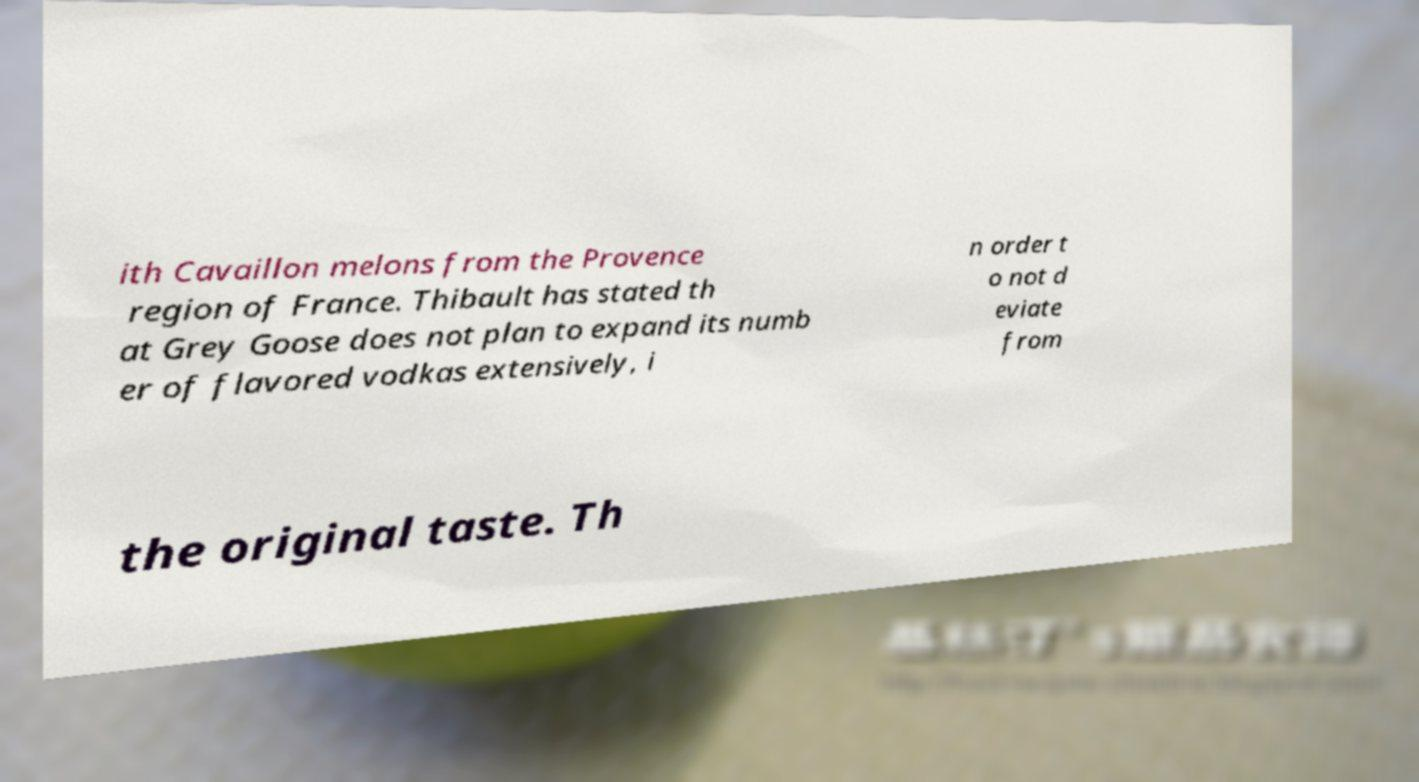Can you read and provide the text displayed in the image?This photo seems to have some interesting text. Can you extract and type it out for me? ith Cavaillon melons from the Provence region of France. Thibault has stated th at Grey Goose does not plan to expand its numb er of flavored vodkas extensively, i n order t o not d eviate from the original taste. Th 